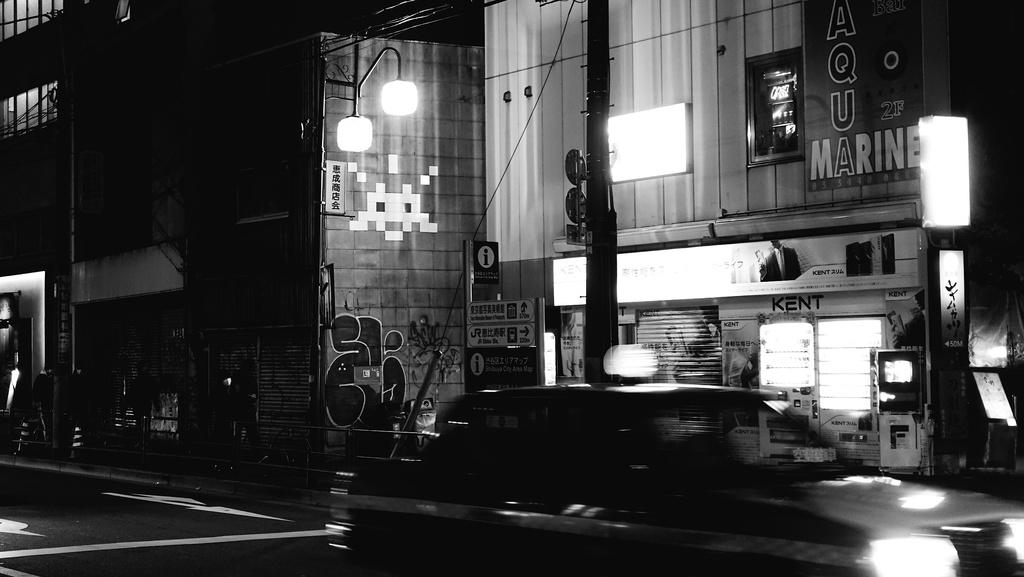What is happening in the image? A vehicle is moving on the road. What can be seen beside the vehicle? There are sign boards beside the vehicle. What is present on poles in the image? Lights are on poles. What type of structures are visible in the image? There are buildings with windows in the image. What is present on the buildings? There are hoardings on the buildings. What kind of artwork can be seen on a wall in the image? Graffiti is present on a wall. How far away is the day in the image? There is no day present in the image; it is a night scene. What type of discussion is taking place between the lights on the poles? There is no discussion taking place in the image; the lights are stationary objects. 